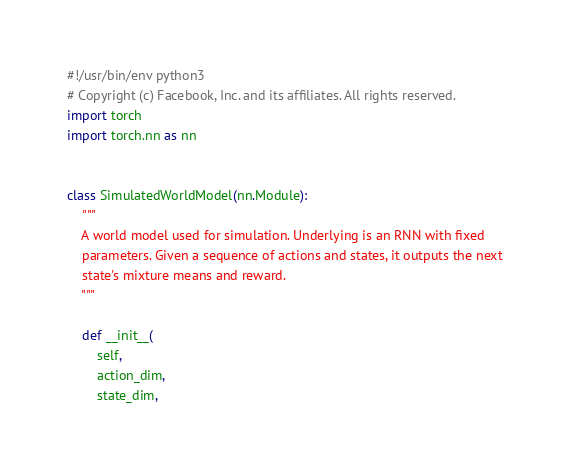<code> <loc_0><loc_0><loc_500><loc_500><_Python_>#!/usr/bin/env python3
# Copyright (c) Facebook, Inc. and its affiliates. All rights reserved.
import torch
import torch.nn as nn


class SimulatedWorldModel(nn.Module):
    """
    A world model used for simulation. Underlying is an RNN with fixed
    parameters. Given a sequence of actions and states, it outputs the next
    state's mixture means and reward.
    """

    def __init__(
        self,
        action_dim,
        state_dim,</code> 